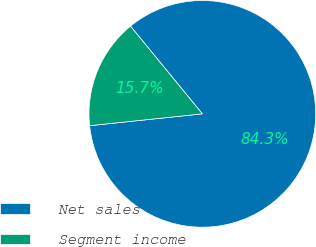Convert chart to OTSL. <chart><loc_0><loc_0><loc_500><loc_500><pie_chart><fcel>Net sales<fcel>Segment income<nl><fcel>84.26%<fcel>15.74%<nl></chart> 